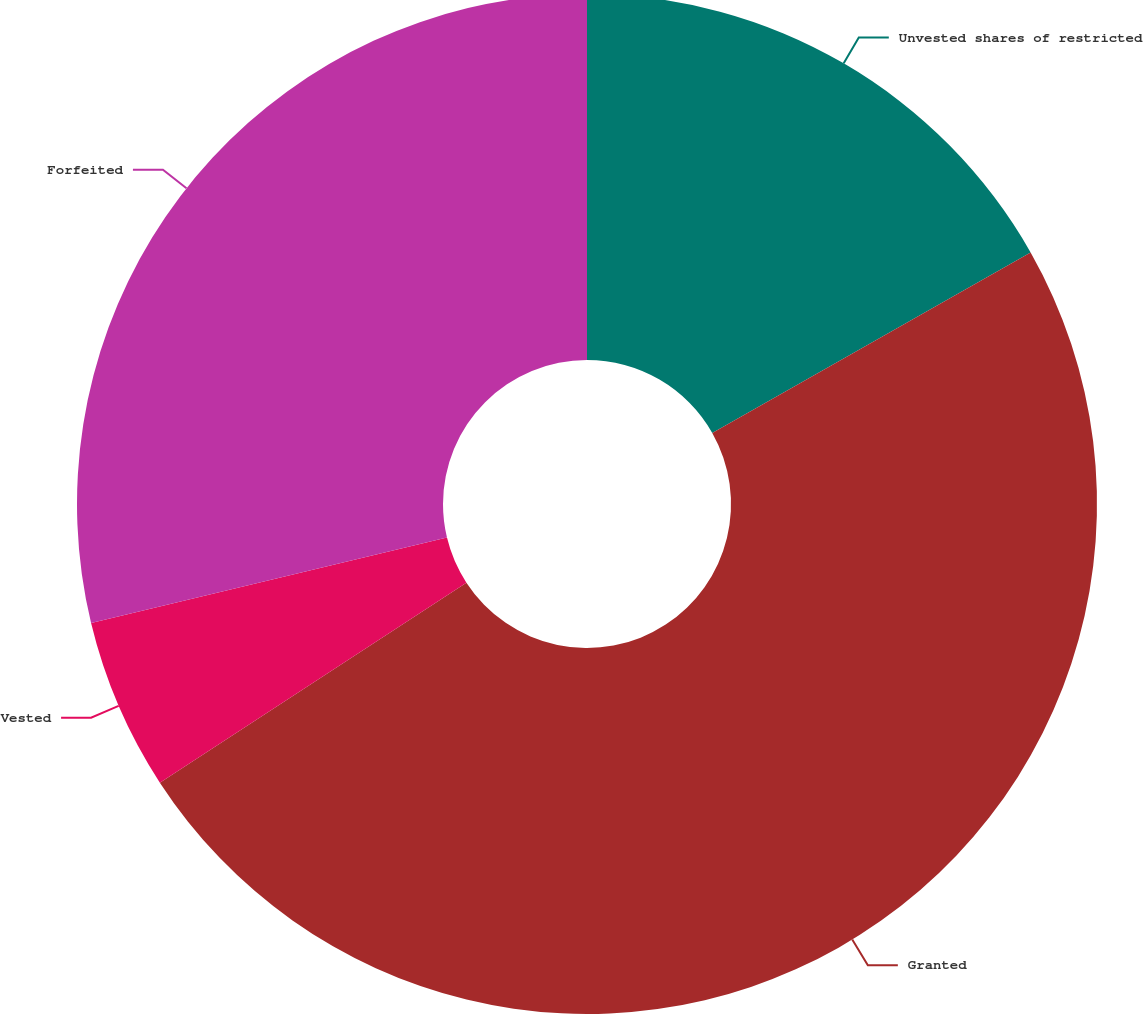Convert chart to OTSL. <chart><loc_0><loc_0><loc_500><loc_500><pie_chart><fcel>Unvested shares of restricted<fcel>Granted<fcel>Vested<fcel>Forfeited<nl><fcel>16.79%<fcel>49.01%<fcel>5.45%<fcel>28.75%<nl></chart> 